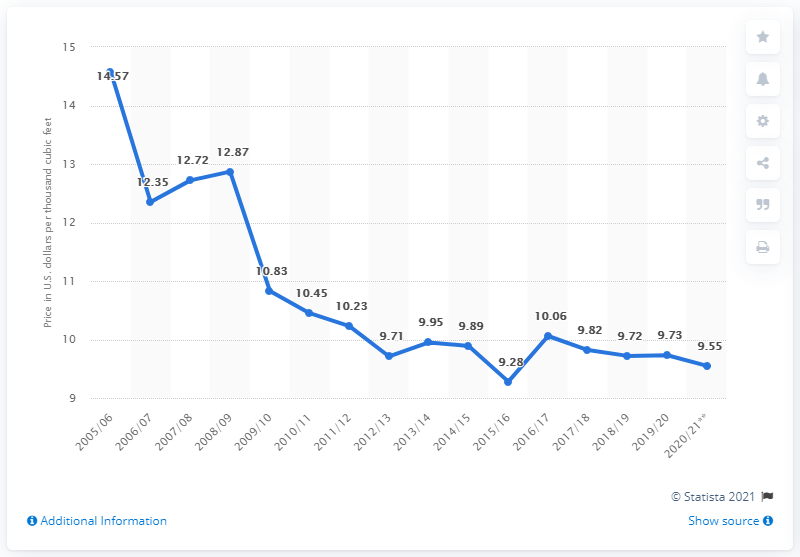Draw attention to some important aspects in this diagram. The average price per thousand cubic feet of natural gas is 9.55. The average of the last five data points is 9.776... The highest value in the blue line chart is 14.57. 